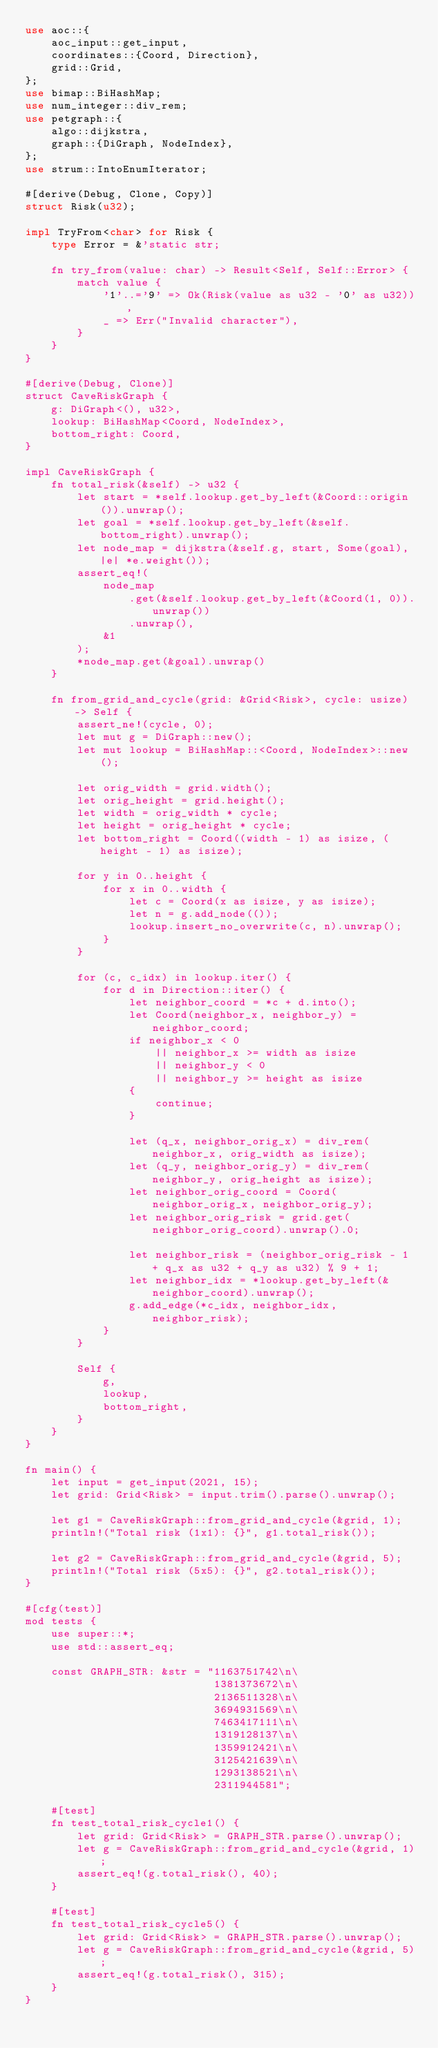<code> <loc_0><loc_0><loc_500><loc_500><_Rust_>use aoc::{
    aoc_input::get_input,
    coordinates::{Coord, Direction},
    grid::Grid,
};
use bimap::BiHashMap;
use num_integer::div_rem;
use petgraph::{
    algo::dijkstra,
    graph::{DiGraph, NodeIndex},
};
use strum::IntoEnumIterator;

#[derive(Debug, Clone, Copy)]
struct Risk(u32);

impl TryFrom<char> for Risk {
    type Error = &'static str;

    fn try_from(value: char) -> Result<Self, Self::Error> {
        match value {
            '1'..='9' => Ok(Risk(value as u32 - '0' as u32)),
            _ => Err("Invalid character"),
        }
    }
}

#[derive(Debug, Clone)]
struct CaveRiskGraph {
    g: DiGraph<(), u32>,
    lookup: BiHashMap<Coord, NodeIndex>,
    bottom_right: Coord,
}

impl CaveRiskGraph {
    fn total_risk(&self) -> u32 {
        let start = *self.lookup.get_by_left(&Coord::origin()).unwrap();
        let goal = *self.lookup.get_by_left(&self.bottom_right).unwrap();
        let node_map = dijkstra(&self.g, start, Some(goal), |e| *e.weight());
        assert_eq!(
            node_map
                .get(&self.lookup.get_by_left(&Coord(1, 0)).unwrap())
                .unwrap(),
            &1
        );
        *node_map.get(&goal).unwrap()
    }

    fn from_grid_and_cycle(grid: &Grid<Risk>, cycle: usize) -> Self {
        assert_ne!(cycle, 0);
        let mut g = DiGraph::new();
        let mut lookup = BiHashMap::<Coord, NodeIndex>::new();

        let orig_width = grid.width();
        let orig_height = grid.height();
        let width = orig_width * cycle;
        let height = orig_height * cycle;
        let bottom_right = Coord((width - 1) as isize, (height - 1) as isize);

        for y in 0..height {
            for x in 0..width {
                let c = Coord(x as isize, y as isize);
                let n = g.add_node(());
                lookup.insert_no_overwrite(c, n).unwrap();
            }
        }

        for (c, c_idx) in lookup.iter() {
            for d in Direction::iter() {
                let neighbor_coord = *c + d.into();
                let Coord(neighbor_x, neighbor_y) = neighbor_coord;
                if neighbor_x < 0
                    || neighbor_x >= width as isize
                    || neighbor_y < 0
                    || neighbor_y >= height as isize
                {
                    continue;
                }

                let (q_x, neighbor_orig_x) = div_rem(neighbor_x, orig_width as isize);
                let (q_y, neighbor_orig_y) = div_rem(neighbor_y, orig_height as isize);
                let neighbor_orig_coord = Coord(neighbor_orig_x, neighbor_orig_y);
                let neighbor_orig_risk = grid.get(neighbor_orig_coord).unwrap().0;

                let neighbor_risk = (neighbor_orig_risk - 1 + q_x as u32 + q_y as u32) % 9 + 1;
                let neighbor_idx = *lookup.get_by_left(&neighbor_coord).unwrap();
                g.add_edge(*c_idx, neighbor_idx, neighbor_risk);
            }
        }

        Self {
            g,
            lookup,
            bottom_right,
        }
    }
}

fn main() {
    let input = get_input(2021, 15);
    let grid: Grid<Risk> = input.trim().parse().unwrap();

    let g1 = CaveRiskGraph::from_grid_and_cycle(&grid, 1);
    println!("Total risk (1x1): {}", g1.total_risk());

    let g2 = CaveRiskGraph::from_grid_and_cycle(&grid, 5);
    println!("Total risk (5x5): {}", g2.total_risk());
}

#[cfg(test)]
mod tests {
    use super::*;
    use std::assert_eq;

    const GRAPH_STR: &str = "1163751742\n\
                             1381373672\n\
                             2136511328\n\
                             3694931569\n\
                             7463417111\n\
                             1319128137\n\
                             1359912421\n\
                             3125421639\n\
                             1293138521\n\
                             2311944581";

    #[test]
    fn test_total_risk_cycle1() {
        let grid: Grid<Risk> = GRAPH_STR.parse().unwrap();
        let g = CaveRiskGraph::from_grid_and_cycle(&grid, 1);
        assert_eq!(g.total_risk(), 40);
    }

    #[test]
    fn test_total_risk_cycle5() {
        let grid: Grid<Risk> = GRAPH_STR.parse().unwrap();
        let g = CaveRiskGraph::from_grid_and_cycle(&grid, 5);
        assert_eq!(g.total_risk(), 315);
    }
}
</code> 